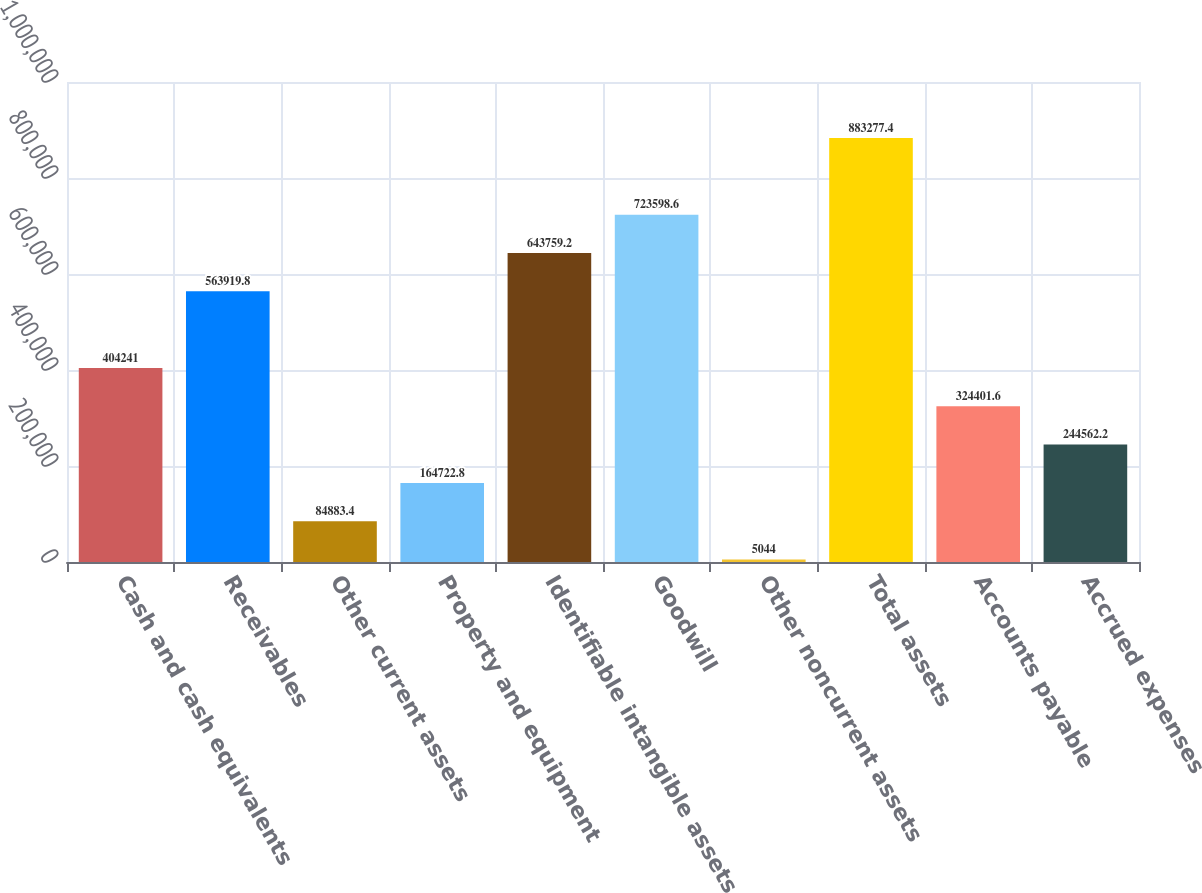<chart> <loc_0><loc_0><loc_500><loc_500><bar_chart><fcel>Cash and cash equivalents<fcel>Receivables<fcel>Other current assets<fcel>Property and equipment<fcel>Identifiable intangible assets<fcel>Goodwill<fcel>Other noncurrent assets<fcel>Total assets<fcel>Accounts payable<fcel>Accrued expenses<nl><fcel>404241<fcel>563920<fcel>84883.4<fcel>164723<fcel>643759<fcel>723599<fcel>5044<fcel>883277<fcel>324402<fcel>244562<nl></chart> 